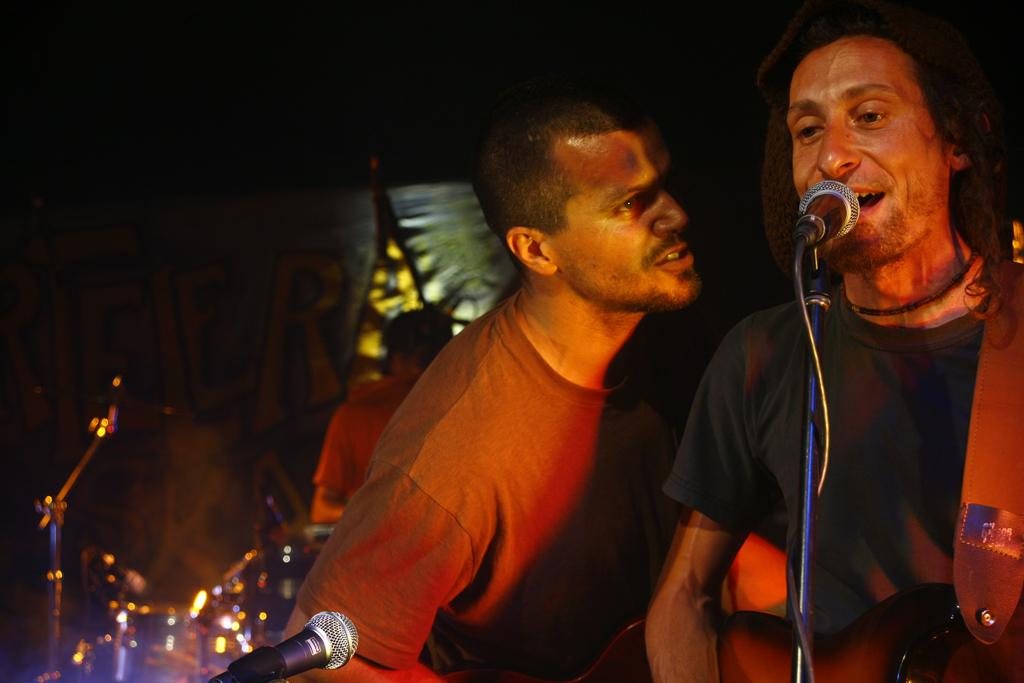What is the main activity of the man in the image? The man is singing with a microphone in front of him. What instrument is the man holding? The man is holding a guitar. Is there anyone else in the image besides the singer? Yes, there is another man standing beside the singer. What is happening in the background of the image? In the background, a man is playing drums. What type of weather can be seen in the image? The image does not depict any weather conditions; it is focused on the musicians and their instruments. 